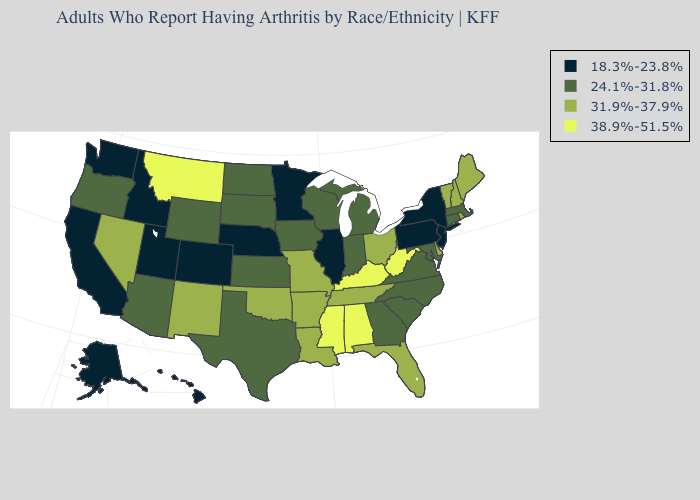Name the states that have a value in the range 24.1%-31.8%?
Give a very brief answer. Arizona, Connecticut, Georgia, Indiana, Iowa, Kansas, Maryland, Massachusetts, Michigan, North Carolina, North Dakota, Oregon, South Carolina, South Dakota, Texas, Virginia, Wisconsin, Wyoming. Does Montana have the highest value in the West?
Give a very brief answer. Yes. Among the states that border Michigan , which have the highest value?
Give a very brief answer. Ohio. What is the highest value in states that border Colorado?
Give a very brief answer. 31.9%-37.9%. What is the value of Maine?
Write a very short answer. 31.9%-37.9%. Does New Mexico have the lowest value in the West?
Quick response, please. No. Does Kansas have a lower value than Arizona?
Answer briefly. No. Which states have the lowest value in the USA?
Write a very short answer. Alaska, California, Colorado, Hawaii, Idaho, Illinois, Minnesota, Nebraska, New Jersey, New York, Pennsylvania, Utah, Washington. Among the states that border Virginia , which have the lowest value?
Answer briefly. Maryland, North Carolina. Does Tennessee have a lower value than Connecticut?
Short answer required. No. Which states have the lowest value in the USA?
Give a very brief answer. Alaska, California, Colorado, Hawaii, Idaho, Illinois, Minnesota, Nebraska, New Jersey, New York, Pennsylvania, Utah, Washington. Which states have the lowest value in the MidWest?
Short answer required. Illinois, Minnesota, Nebraska. Among the states that border Wisconsin , which have the lowest value?
Concise answer only. Illinois, Minnesota. Name the states that have a value in the range 38.9%-51.5%?
Write a very short answer. Alabama, Kentucky, Mississippi, Montana, West Virginia. What is the lowest value in states that border Arizona?
Be succinct. 18.3%-23.8%. 